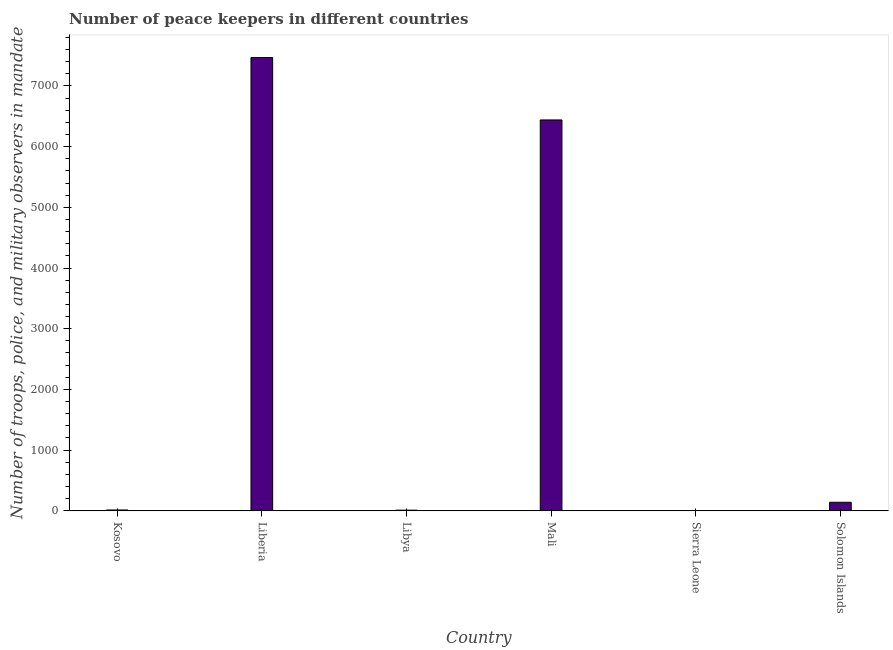Does the graph contain grids?
Give a very brief answer. No. What is the title of the graph?
Your answer should be very brief. Number of peace keepers in different countries. What is the label or title of the Y-axis?
Your response must be concise. Number of troops, police, and military observers in mandate. What is the number of peace keepers in Liberia?
Your answer should be very brief. 7467. Across all countries, what is the maximum number of peace keepers?
Ensure brevity in your answer.  7467. In which country was the number of peace keepers maximum?
Keep it short and to the point. Liberia. In which country was the number of peace keepers minimum?
Ensure brevity in your answer.  Sierra Leone. What is the sum of the number of peace keepers?
Ensure brevity in your answer.  1.41e+04. What is the difference between the number of peace keepers in Mali and Sierra Leone?
Your answer should be compact. 6435. What is the average number of peace keepers per country?
Your response must be concise. 2346. What is the median number of peace keepers?
Offer a terse response. 77.5. In how many countries, is the number of peace keepers greater than 6200 ?
Give a very brief answer. 2. What is the ratio of the number of peace keepers in Liberia to that in Libya?
Make the answer very short. 678.82. What is the difference between the highest and the second highest number of peace keepers?
Provide a succinct answer. 1028. Is the sum of the number of peace keepers in Kosovo and Mali greater than the maximum number of peace keepers across all countries?
Provide a short and direct response. No. What is the difference between the highest and the lowest number of peace keepers?
Offer a very short reply. 7463. In how many countries, is the number of peace keepers greater than the average number of peace keepers taken over all countries?
Ensure brevity in your answer.  2. How many bars are there?
Give a very brief answer. 6. Are all the bars in the graph horizontal?
Ensure brevity in your answer.  No. What is the difference between two consecutive major ticks on the Y-axis?
Your answer should be very brief. 1000. Are the values on the major ticks of Y-axis written in scientific E-notation?
Your answer should be compact. No. What is the Number of troops, police, and military observers in mandate of Kosovo?
Your answer should be compact. 14. What is the Number of troops, police, and military observers in mandate in Liberia?
Provide a short and direct response. 7467. What is the Number of troops, police, and military observers in mandate in Mali?
Ensure brevity in your answer.  6439. What is the Number of troops, police, and military observers in mandate of Sierra Leone?
Make the answer very short. 4. What is the Number of troops, police, and military observers in mandate of Solomon Islands?
Provide a succinct answer. 141. What is the difference between the Number of troops, police, and military observers in mandate in Kosovo and Liberia?
Offer a very short reply. -7453. What is the difference between the Number of troops, police, and military observers in mandate in Kosovo and Mali?
Give a very brief answer. -6425. What is the difference between the Number of troops, police, and military observers in mandate in Kosovo and Sierra Leone?
Offer a very short reply. 10. What is the difference between the Number of troops, police, and military observers in mandate in Kosovo and Solomon Islands?
Offer a terse response. -127. What is the difference between the Number of troops, police, and military observers in mandate in Liberia and Libya?
Provide a succinct answer. 7456. What is the difference between the Number of troops, police, and military observers in mandate in Liberia and Mali?
Your answer should be very brief. 1028. What is the difference between the Number of troops, police, and military observers in mandate in Liberia and Sierra Leone?
Your answer should be very brief. 7463. What is the difference between the Number of troops, police, and military observers in mandate in Liberia and Solomon Islands?
Your response must be concise. 7326. What is the difference between the Number of troops, police, and military observers in mandate in Libya and Mali?
Offer a very short reply. -6428. What is the difference between the Number of troops, police, and military observers in mandate in Libya and Solomon Islands?
Your answer should be very brief. -130. What is the difference between the Number of troops, police, and military observers in mandate in Mali and Sierra Leone?
Your answer should be very brief. 6435. What is the difference between the Number of troops, police, and military observers in mandate in Mali and Solomon Islands?
Keep it short and to the point. 6298. What is the difference between the Number of troops, police, and military observers in mandate in Sierra Leone and Solomon Islands?
Offer a very short reply. -137. What is the ratio of the Number of troops, police, and military observers in mandate in Kosovo to that in Liberia?
Provide a succinct answer. 0. What is the ratio of the Number of troops, police, and military observers in mandate in Kosovo to that in Libya?
Make the answer very short. 1.27. What is the ratio of the Number of troops, police, and military observers in mandate in Kosovo to that in Mali?
Your response must be concise. 0. What is the ratio of the Number of troops, police, and military observers in mandate in Kosovo to that in Solomon Islands?
Make the answer very short. 0.1. What is the ratio of the Number of troops, police, and military observers in mandate in Liberia to that in Libya?
Ensure brevity in your answer.  678.82. What is the ratio of the Number of troops, police, and military observers in mandate in Liberia to that in Mali?
Your answer should be compact. 1.16. What is the ratio of the Number of troops, police, and military observers in mandate in Liberia to that in Sierra Leone?
Make the answer very short. 1866.75. What is the ratio of the Number of troops, police, and military observers in mandate in Liberia to that in Solomon Islands?
Your response must be concise. 52.96. What is the ratio of the Number of troops, police, and military observers in mandate in Libya to that in Mali?
Provide a succinct answer. 0. What is the ratio of the Number of troops, police, and military observers in mandate in Libya to that in Sierra Leone?
Ensure brevity in your answer.  2.75. What is the ratio of the Number of troops, police, and military observers in mandate in Libya to that in Solomon Islands?
Offer a terse response. 0.08. What is the ratio of the Number of troops, police, and military observers in mandate in Mali to that in Sierra Leone?
Offer a very short reply. 1609.75. What is the ratio of the Number of troops, police, and military observers in mandate in Mali to that in Solomon Islands?
Make the answer very short. 45.67. What is the ratio of the Number of troops, police, and military observers in mandate in Sierra Leone to that in Solomon Islands?
Keep it short and to the point. 0.03. 